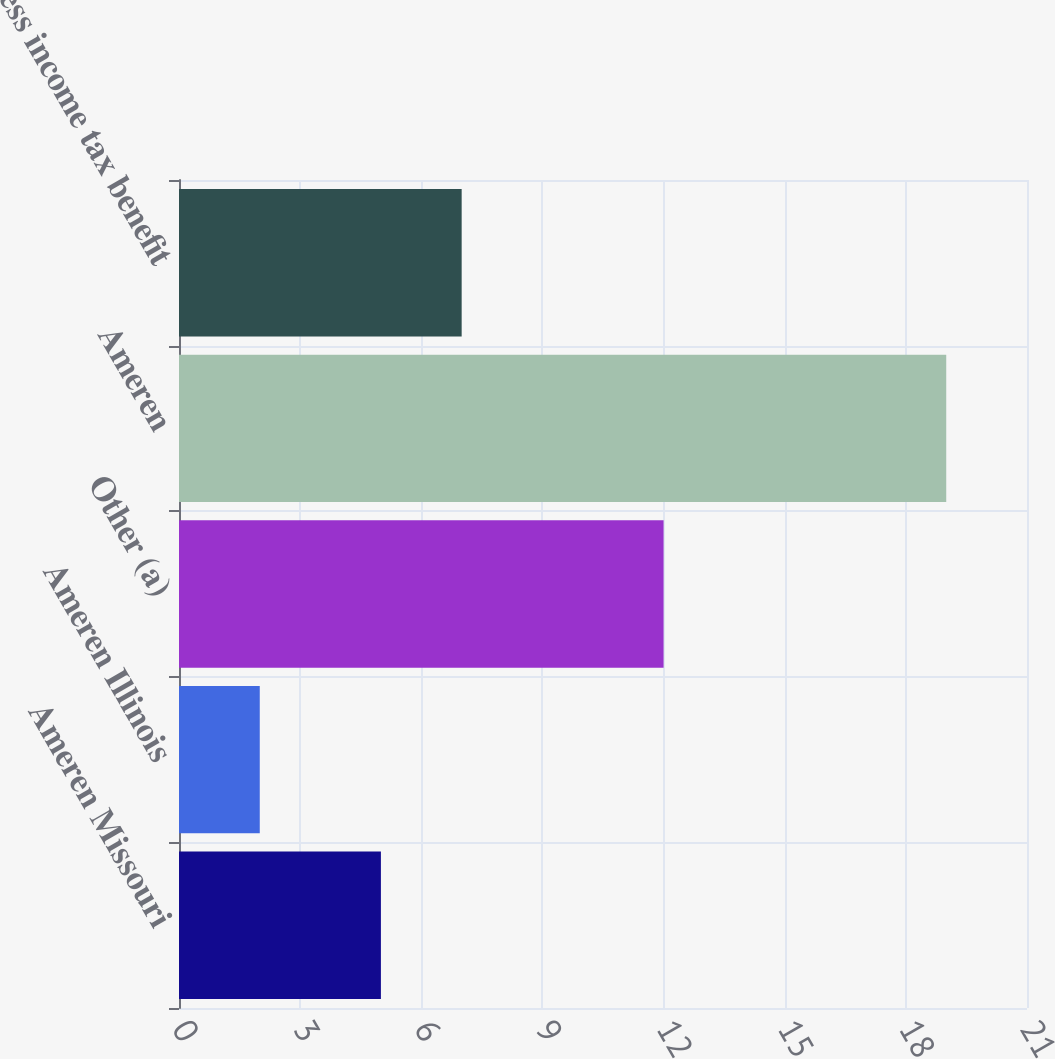Convert chart to OTSL. <chart><loc_0><loc_0><loc_500><loc_500><bar_chart><fcel>Ameren Missouri<fcel>Ameren Illinois<fcel>Other (a)<fcel>Ameren<fcel>Less income tax benefit<nl><fcel>5<fcel>2<fcel>12<fcel>19<fcel>7<nl></chart> 